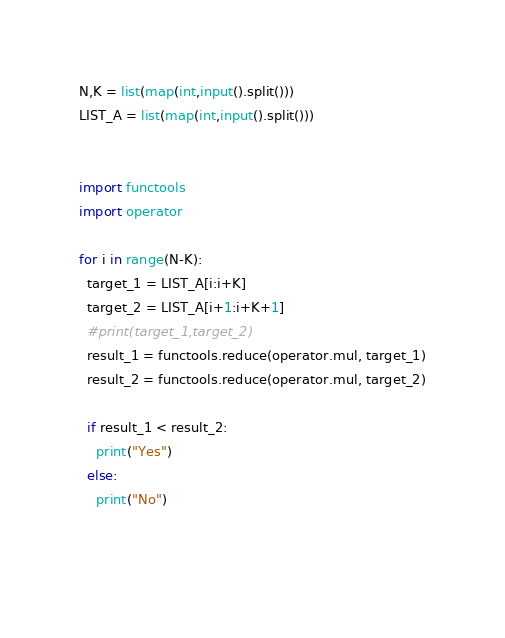Convert code to text. <code><loc_0><loc_0><loc_500><loc_500><_Python_>N,K = list(map(int,input().split()))
LIST_A = list(map(int,input().split()))


import functools
import operator

for i in range(N-K):
  target_1 = LIST_A[i:i+K]
  target_2 = LIST_A[i+1:i+K+1]
  #print(target_1,target_2)
  result_1 = functools.reduce(operator.mul, target_1)
  result_2 = functools.reduce(operator.mul, target_2)
    
  if result_1 < result_2:
    print("Yes")
  else:
    print("No")

	

</code> 